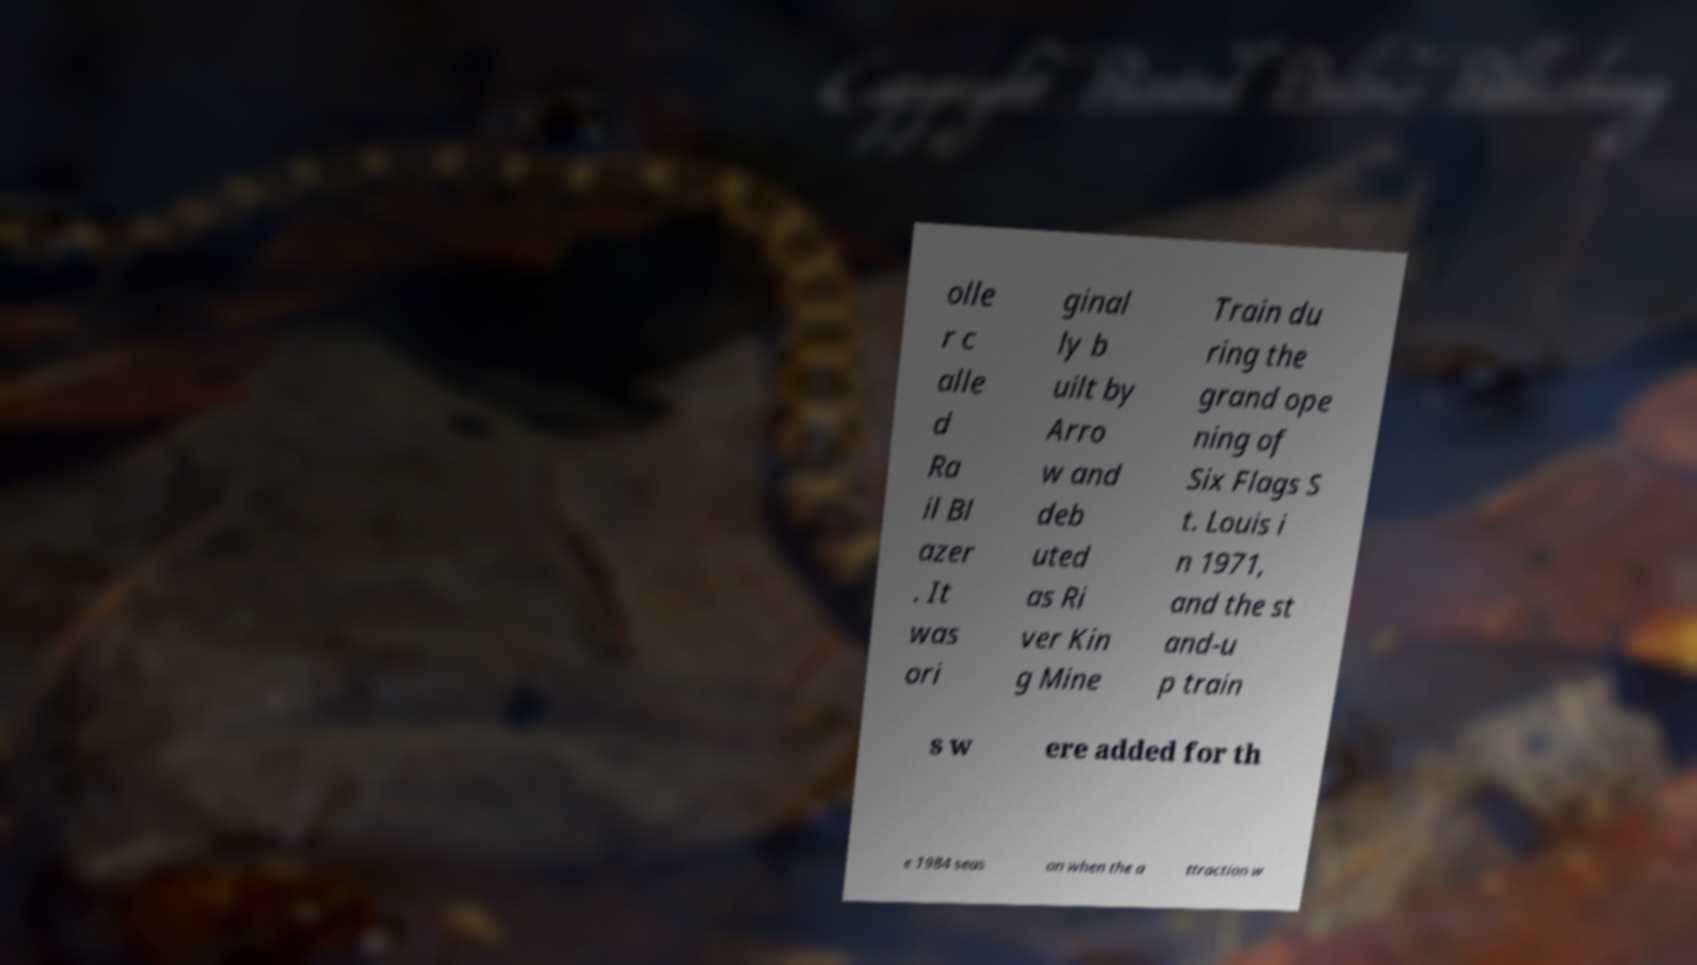Please read and relay the text visible in this image. What does it say? olle r c alle d Ra il Bl azer . It was ori ginal ly b uilt by Arro w and deb uted as Ri ver Kin g Mine Train du ring the grand ope ning of Six Flags S t. Louis i n 1971, and the st and-u p train s w ere added for th e 1984 seas on when the a ttraction w 